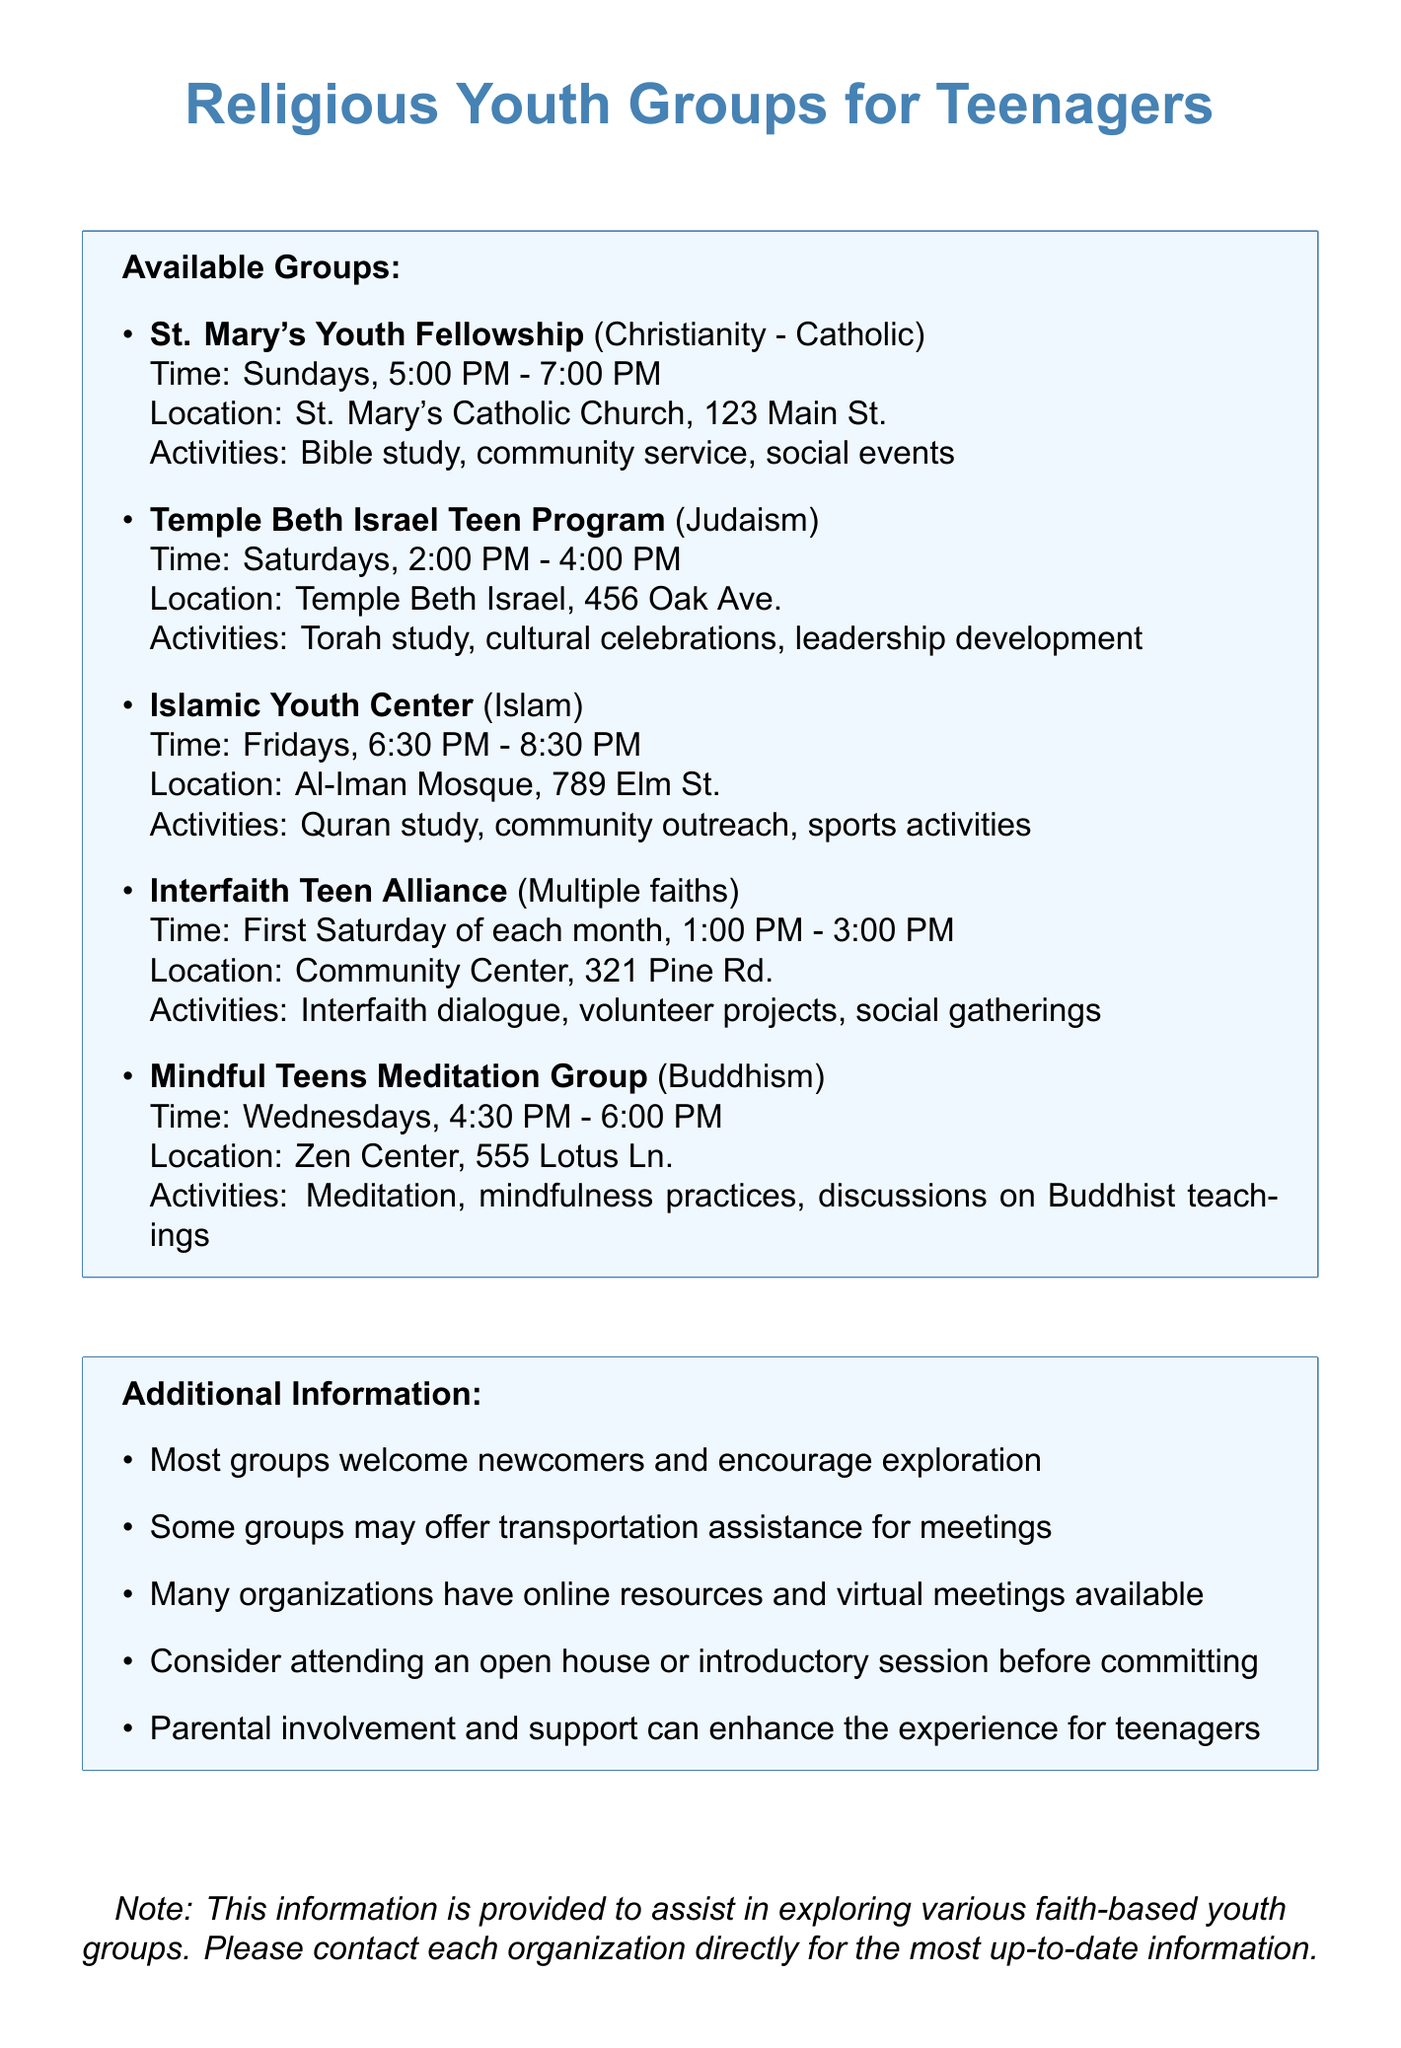What is the name of the Catholic youth group? The document provides a list of youth groups, and the one specified for Catholic youth is "St. Mary's Youth Fellowship."
Answer: St. Mary's Youth Fellowship What day does the Islamic Youth Center hold meetings? The Islamic Youth Center's meetings occur on Fridays, as listed in the document.
Answer: Fridays Where is the Mindful Teens Meditation Group located? The document states that the Mindful Teens Meditation Group is held at Zen Center, which is located at 555 Lotus Ln.
Answer: Zen Center, 555 Lotus Ln What activities does the Interfaith Teen Alliance offer? The document outlines the activities of the Interfaith Teen Alliance, which includes interfaith dialogue, volunteer projects, and social gatherings.
Answer: Interfaith dialogue, volunteer projects, social gatherings How often does the Temple Beth Israel Teen Program meet? The document indicates that the Temple Beth Israel Teen Program meets weekly on Saturdays.
Answer: Weekly What time does St. Mary's Youth Fellowship meet? According to the document, the meeting time for St. Mary's Youth Fellowship is specified as Sundays from 5:00 PM to 7:00 PM.
Answer: 5:00 PM - 7:00 PM What kind of assistance might some groups provide? The document mentions that some youth groups may offer transportation assistance for meetings, which is a helpful service for attendees.
Answer: Transportation assistance What format might some youth groups offer for their meetings? The document states that many organizations have resources available online and may also conduct virtual meetings.
Answer: Online resources, virtual meetings 